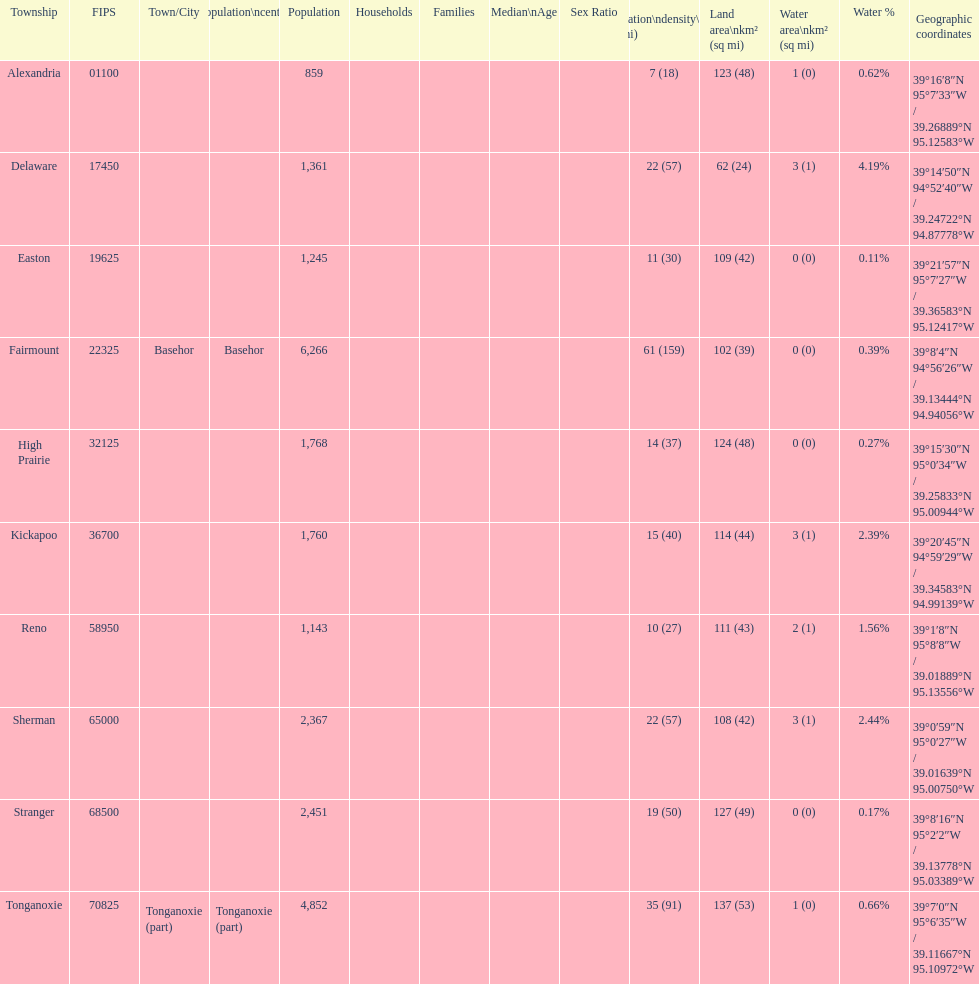How many townships have populations over 2,000? 4. 